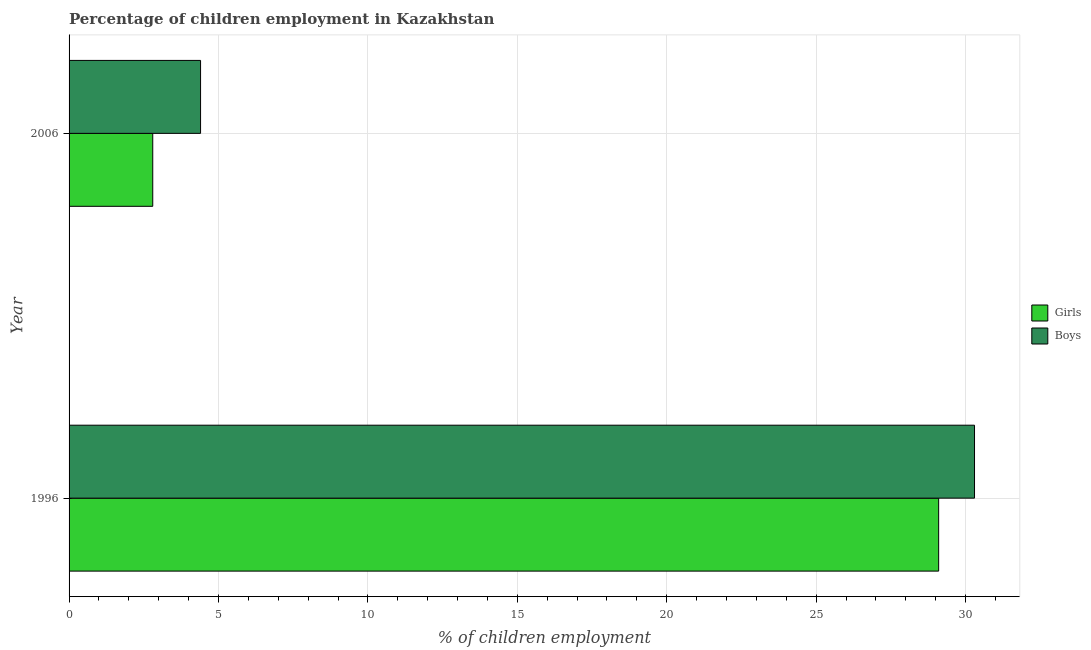How many different coloured bars are there?
Give a very brief answer. 2. How many groups of bars are there?
Ensure brevity in your answer.  2. Are the number of bars per tick equal to the number of legend labels?
Make the answer very short. Yes. Across all years, what is the maximum percentage of employed girls?
Provide a succinct answer. 29.1. Across all years, what is the minimum percentage of employed boys?
Your answer should be compact. 4.4. In which year was the percentage of employed girls maximum?
Give a very brief answer. 1996. In which year was the percentage of employed girls minimum?
Your answer should be very brief. 2006. What is the total percentage of employed boys in the graph?
Offer a terse response. 34.7. What is the difference between the percentage of employed girls in 1996 and that in 2006?
Your answer should be very brief. 26.3. What is the difference between the percentage of employed boys in 1996 and the percentage of employed girls in 2006?
Offer a terse response. 27.5. What is the average percentage of employed girls per year?
Offer a terse response. 15.95. What is the ratio of the percentage of employed girls in 1996 to that in 2006?
Provide a short and direct response. 10.39. Is the percentage of employed boys in 1996 less than that in 2006?
Your answer should be very brief. No. In how many years, is the percentage of employed boys greater than the average percentage of employed boys taken over all years?
Your answer should be compact. 1. What does the 1st bar from the top in 1996 represents?
Make the answer very short. Boys. What does the 2nd bar from the bottom in 1996 represents?
Your answer should be very brief. Boys. How many bars are there?
Give a very brief answer. 4. How many years are there in the graph?
Offer a very short reply. 2. Does the graph contain any zero values?
Provide a short and direct response. No. Does the graph contain grids?
Keep it short and to the point. Yes. Where does the legend appear in the graph?
Your answer should be very brief. Center right. How many legend labels are there?
Your answer should be very brief. 2. What is the title of the graph?
Give a very brief answer. Percentage of children employment in Kazakhstan. What is the label or title of the X-axis?
Your answer should be very brief. % of children employment. What is the % of children employment in Girls in 1996?
Provide a short and direct response. 29.1. What is the % of children employment of Boys in 1996?
Offer a terse response. 30.3. Across all years, what is the maximum % of children employment in Girls?
Keep it short and to the point. 29.1. Across all years, what is the maximum % of children employment in Boys?
Provide a short and direct response. 30.3. What is the total % of children employment of Girls in the graph?
Ensure brevity in your answer.  31.9. What is the total % of children employment of Boys in the graph?
Offer a terse response. 34.7. What is the difference between the % of children employment in Girls in 1996 and that in 2006?
Provide a short and direct response. 26.3. What is the difference between the % of children employment of Boys in 1996 and that in 2006?
Offer a terse response. 25.9. What is the difference between the % of children employment of Girls in 1996 and the % of children employment of Boys in 2006?
Your answer should be compact. 24.7. What is the average % of children employment in Girls per year?
Your answer should be compact. 15.95. What is the average % of children employment in Boys per year?
Your response must be concise. 17.35. In the year 1996, what is the difference between the % of children employment in Girls and % of children employment in Boys?
Provide a succinct answer. -1.2. In the year 2006, what is the difference between the % of children employment in Girls and % of children employment in Boys?
Your answer should be compact. -1.6. What is the ratio of the % of children employment in Girls in 1996 to that in 2006?
Provide a short and direct response. 10.39. What is the ratio of the % of children employment of Boys in 1996 to that in 2006?
Give a very brief answer. 6.89. What is the difference between the highest and the second highest % of children employment in Girls?
Offer a terse response. 26.3. What is the difference between the highest and the second highest % of children employment in Boys?
Your answer should be compact. 25.9. What is the difference between the highest and the lowest % of children employment in Girls?
Your response must be concise. 26.3. What is the difference between the highest and the lowest % of children employment of Boys?
Your answer should be compact. 25.9. 